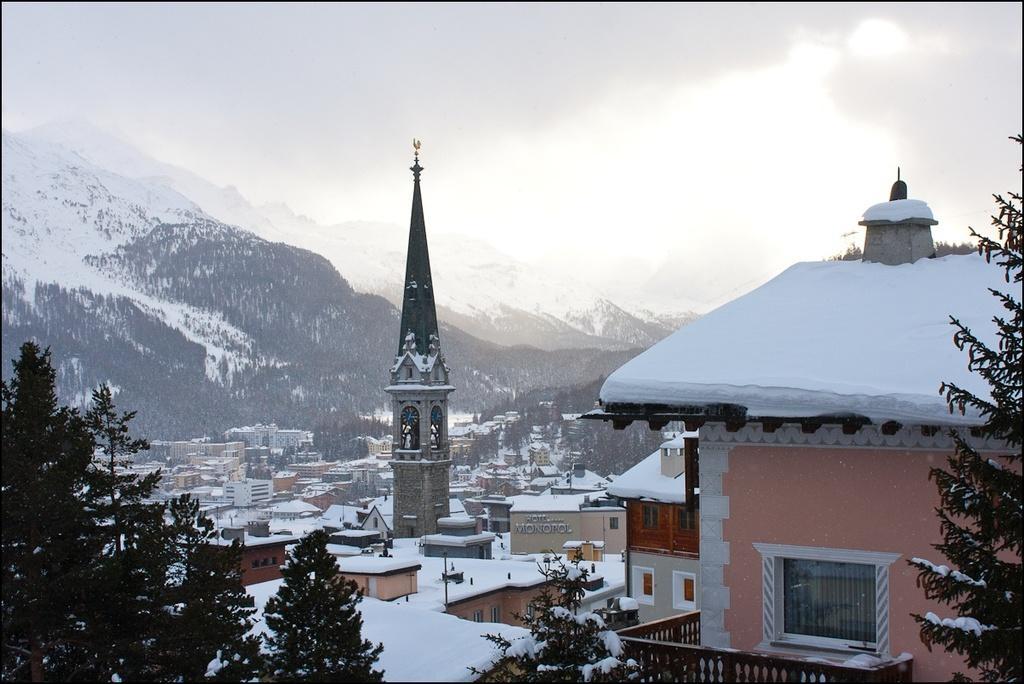Can you describe this image briefly? In the picture there are houses covered with the snow, there are trees, beside there are mountains covered with the snow, there is the sky. 